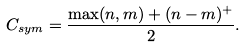Convert formula to latex. <formula><loc_0><loc_0><loc_500><loc_500>C _ { s y m } = \frac { \max ( n , m ) + ( n - m ) ^ { + } } { 2 } .</formula> 